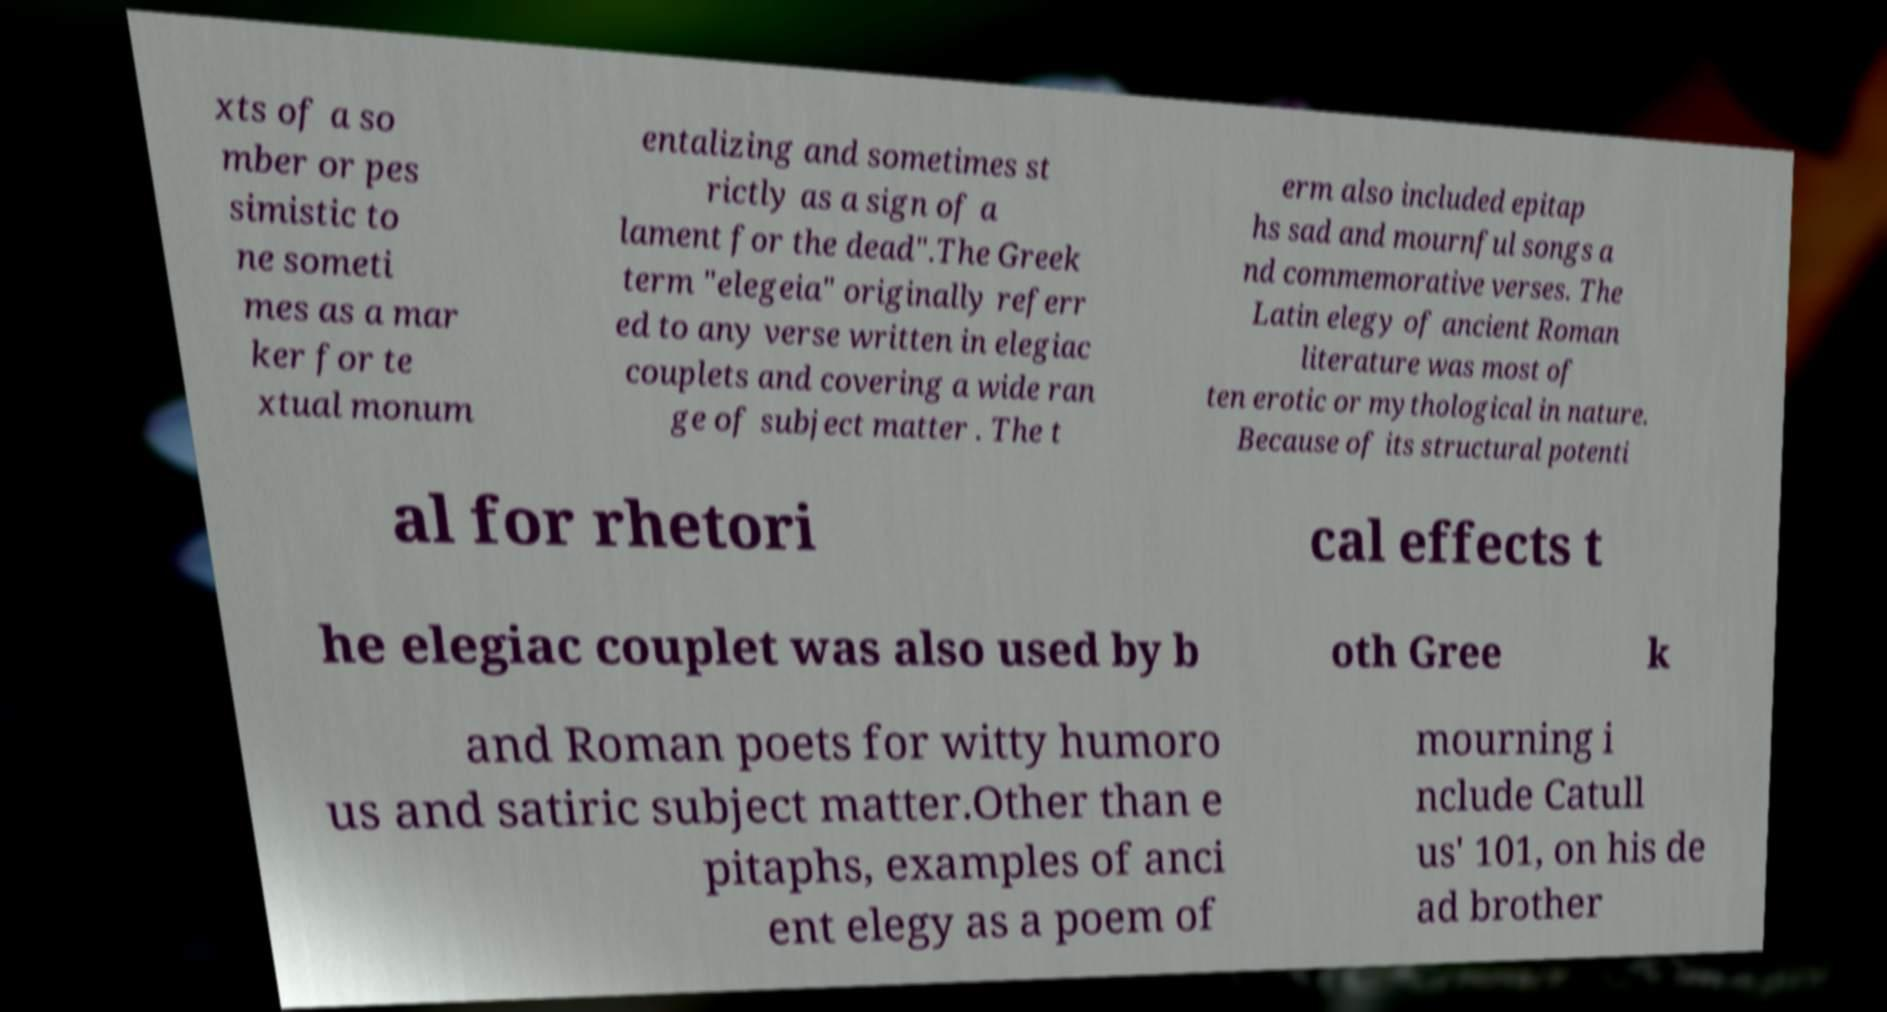Could you assist in decoding the text presented in this image and type it out clearly? xts of a so mber or pes simistic to ne someti mes as a mar ker for te xtual monum entalizing and sometimes st rictly as a sign of a lament for the dead".The Greek term "elegeia" originally referr ed to any verse written in elegiac couplets and covering a wide ran ge of subject matter . The t erm also included epitap hs sad and mournful songs a nd commemorative verses. The Latin elegy of ancient Roman literature was most of ten erotic or mythological in nature. Because of its structural potenti al for rhetori cal effects t he elegiac couplet was also used by b oth Gree k and Roman poets for witty humoro us and satiric subject matter.Other than e pitaphs, examples of anci ent elegy as a poem of mourning i nclude Catull us' 101, on his de ad brother 